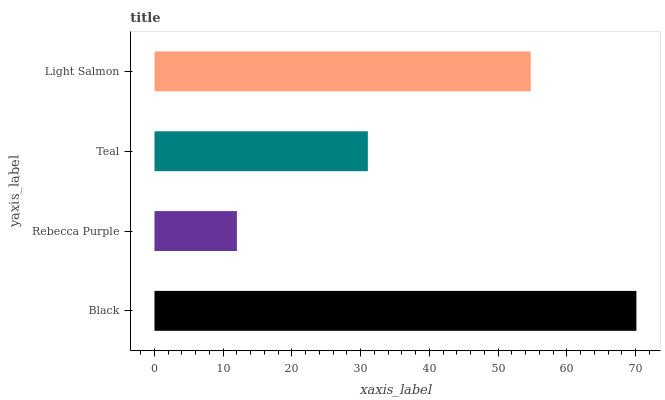Is Rebecca Purple the minimum?
Answer yes or no. Yes. Is Black the maximum?
Answer yes or no. Yes. Is Teal the minimum?
Answer yes or no. No. Is Teal the maximum?
Answer yes or no. No. Is Teal greater than Rebecca Purple?
Answer yes or no. Yes. Is Rebecca Purple less than Teal?
Answer yes or no. Yes. Is Rebecca Purple greater than Teal?
Answer yes or no. No. Is Teal less than Rebecca Purple?
Answer yes or no. No. Is Light Salmon the high median?
Answer yes or no. Yes. Is Teal the low median?
Answer yes or no. Yes. Is Rebecca Purple the high median?
Answer yes or no. No. Is Rebecca Purple the low median?
Answer yes or no. No. 